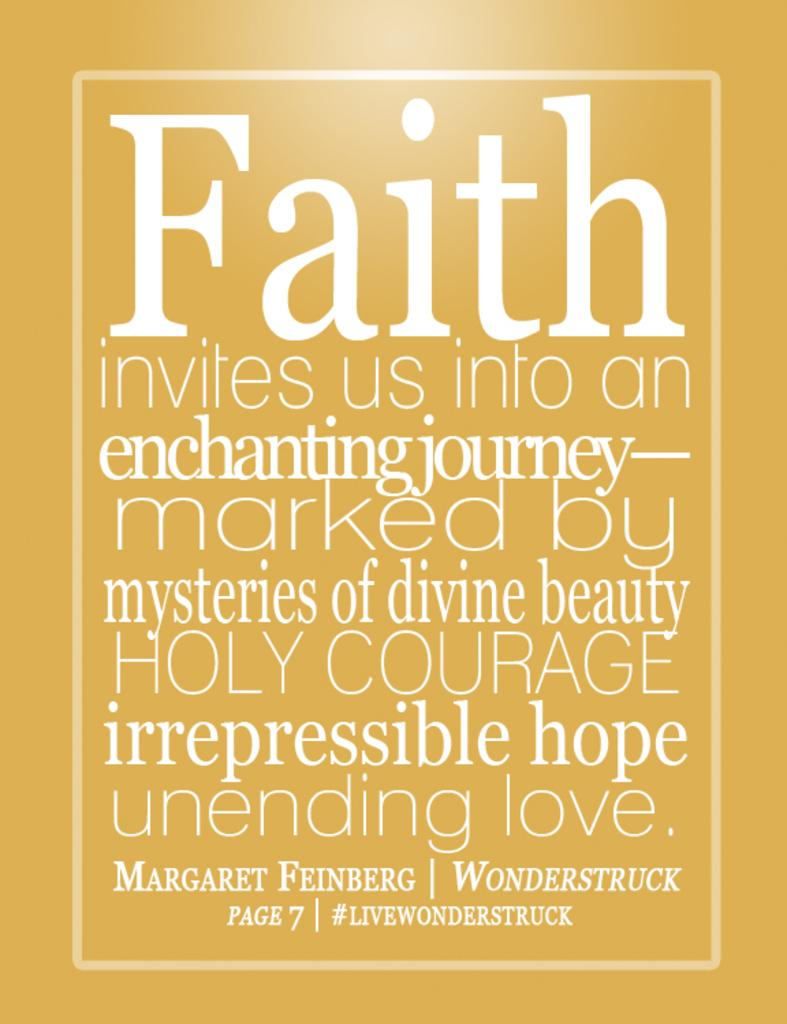Provide a one-sentence caption for the provided image. A yellowish colored poster with the largest word being faith. 